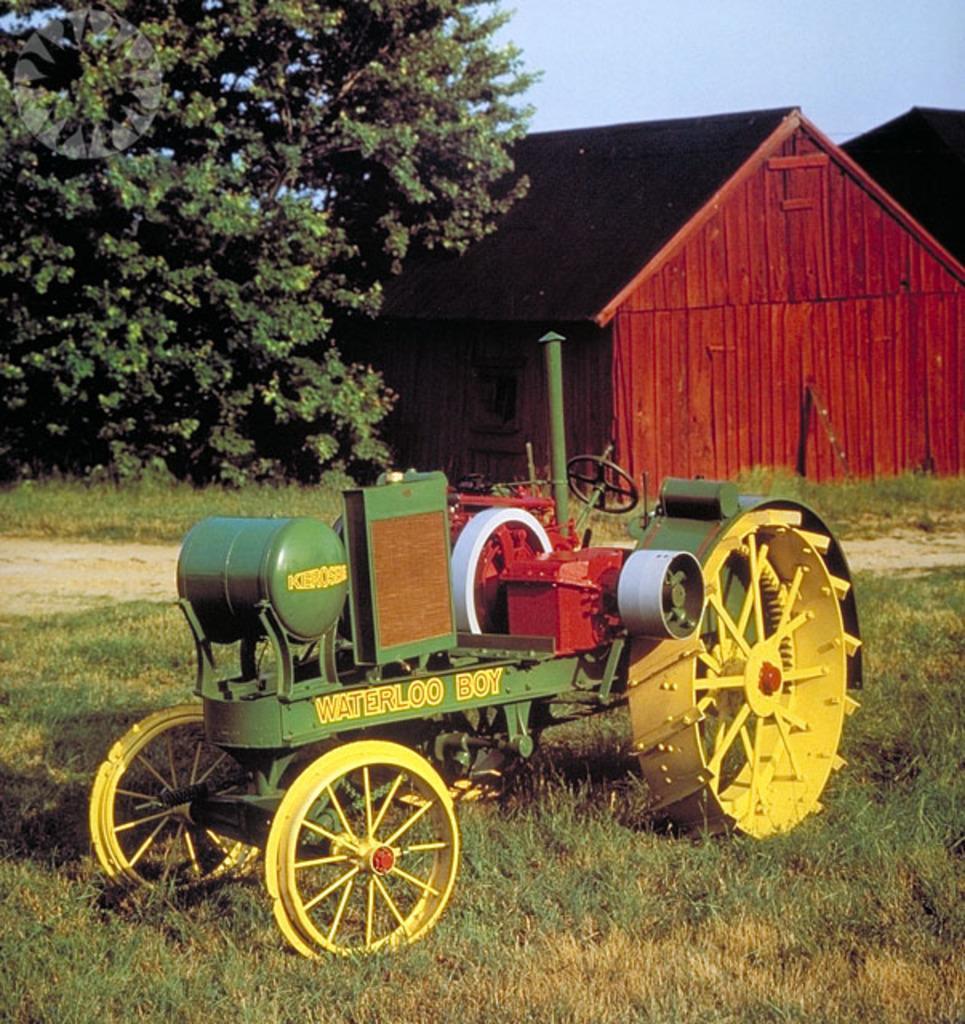Please provide a concise description of this image. In this image there is a vehicle on the ground. There is text on the vehicle. There is grass on the ground. Behind the vehicle there are wooden houses. To the left there is a tree. At the top there is the sky. 